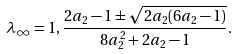<formula> <loc_0><loc_0><loc_500><loc_500>\lambda _ { \infty } = 1 , \frac { 2 a _ { 2 } - 1 \pm \sqrt { 2 a _ { 2 } ( 6 a _ { 2 } - 1 ) } } { 8 a _ { 2 } ^ { 2 } + 2 a _ { 2 } - 1 } .</formula> 